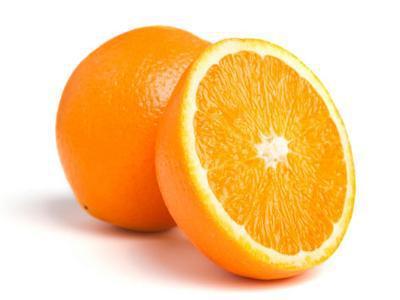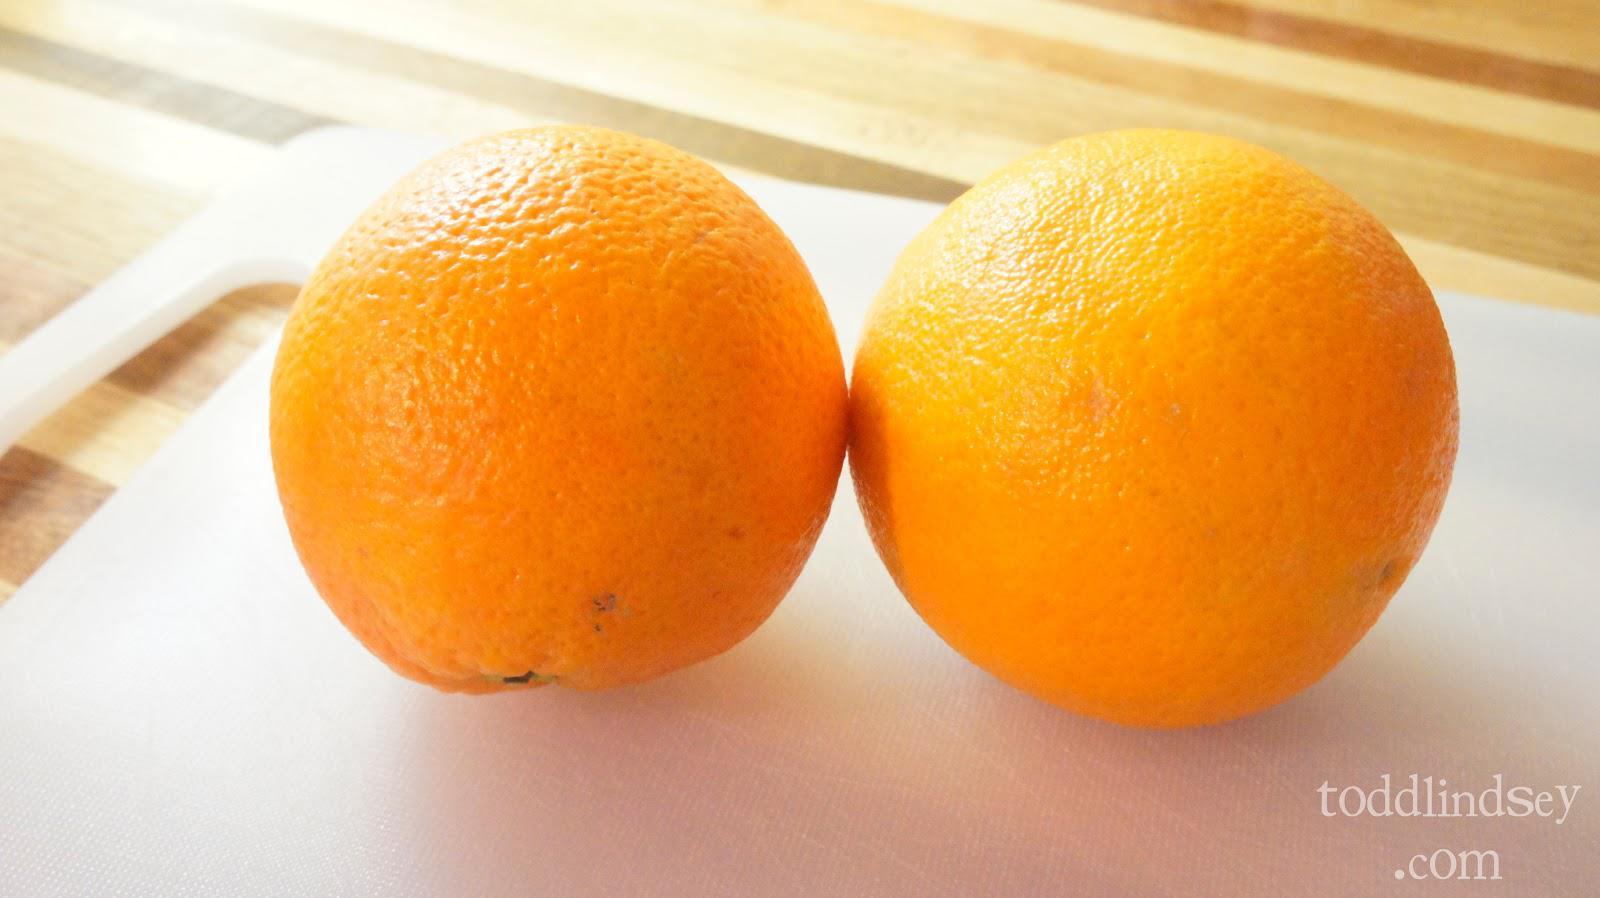The first image is the image on the left, the second image is the image on the right. Assess this claim about the two images: "The right image contains at least one orange that is sliced in half.". Correct or not? Answer yes or no. No. The first image is the image on the left, the second image is the image on the right. For the images shown, is this caption "There are three whole oranges and a half an orange in the image pair." true? Answer yes or no. Yes. 